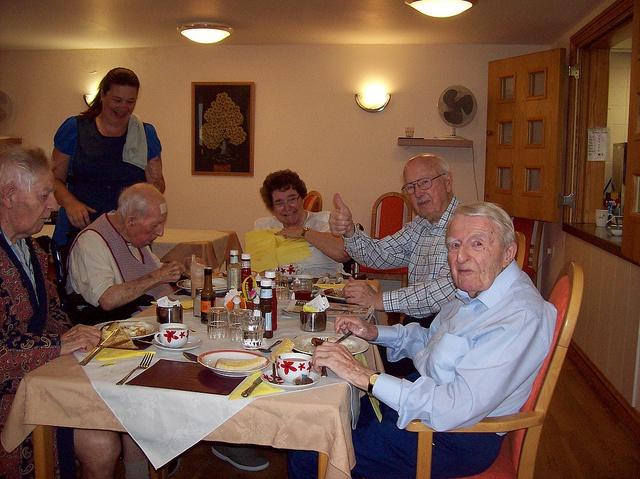Describe the objects in this image and their specific colors. I can see dining table in black, darkgray, gray, tan, and maroon tones, people in black, darkgray, navy, and brown tones, people in black, maroon, and brown tones, people in black, maroon, and gray tones, and people in black, brown, and maroon tones in this image. 